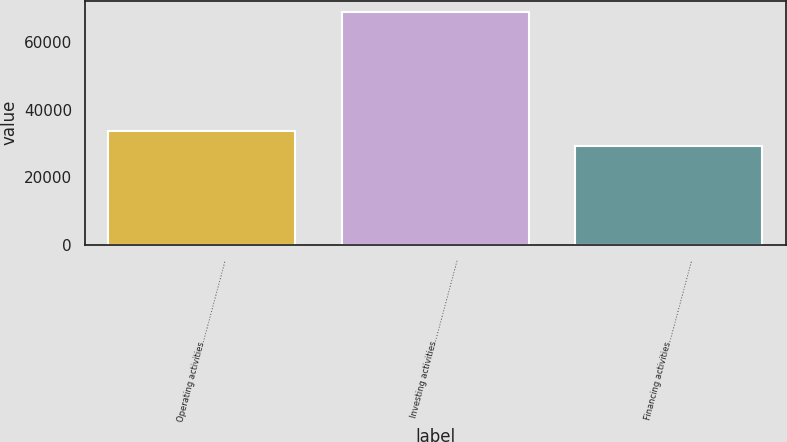<chart> <loc_0><loc_0><loc_500><loc_500><bar_chart><fcel>Operating activities…………………………<fcel>Investing activities…………………………<fcel>Financing activities…………………………<nl><fcel>33871<fcel>68884<fcel>29433<nl></chart> 